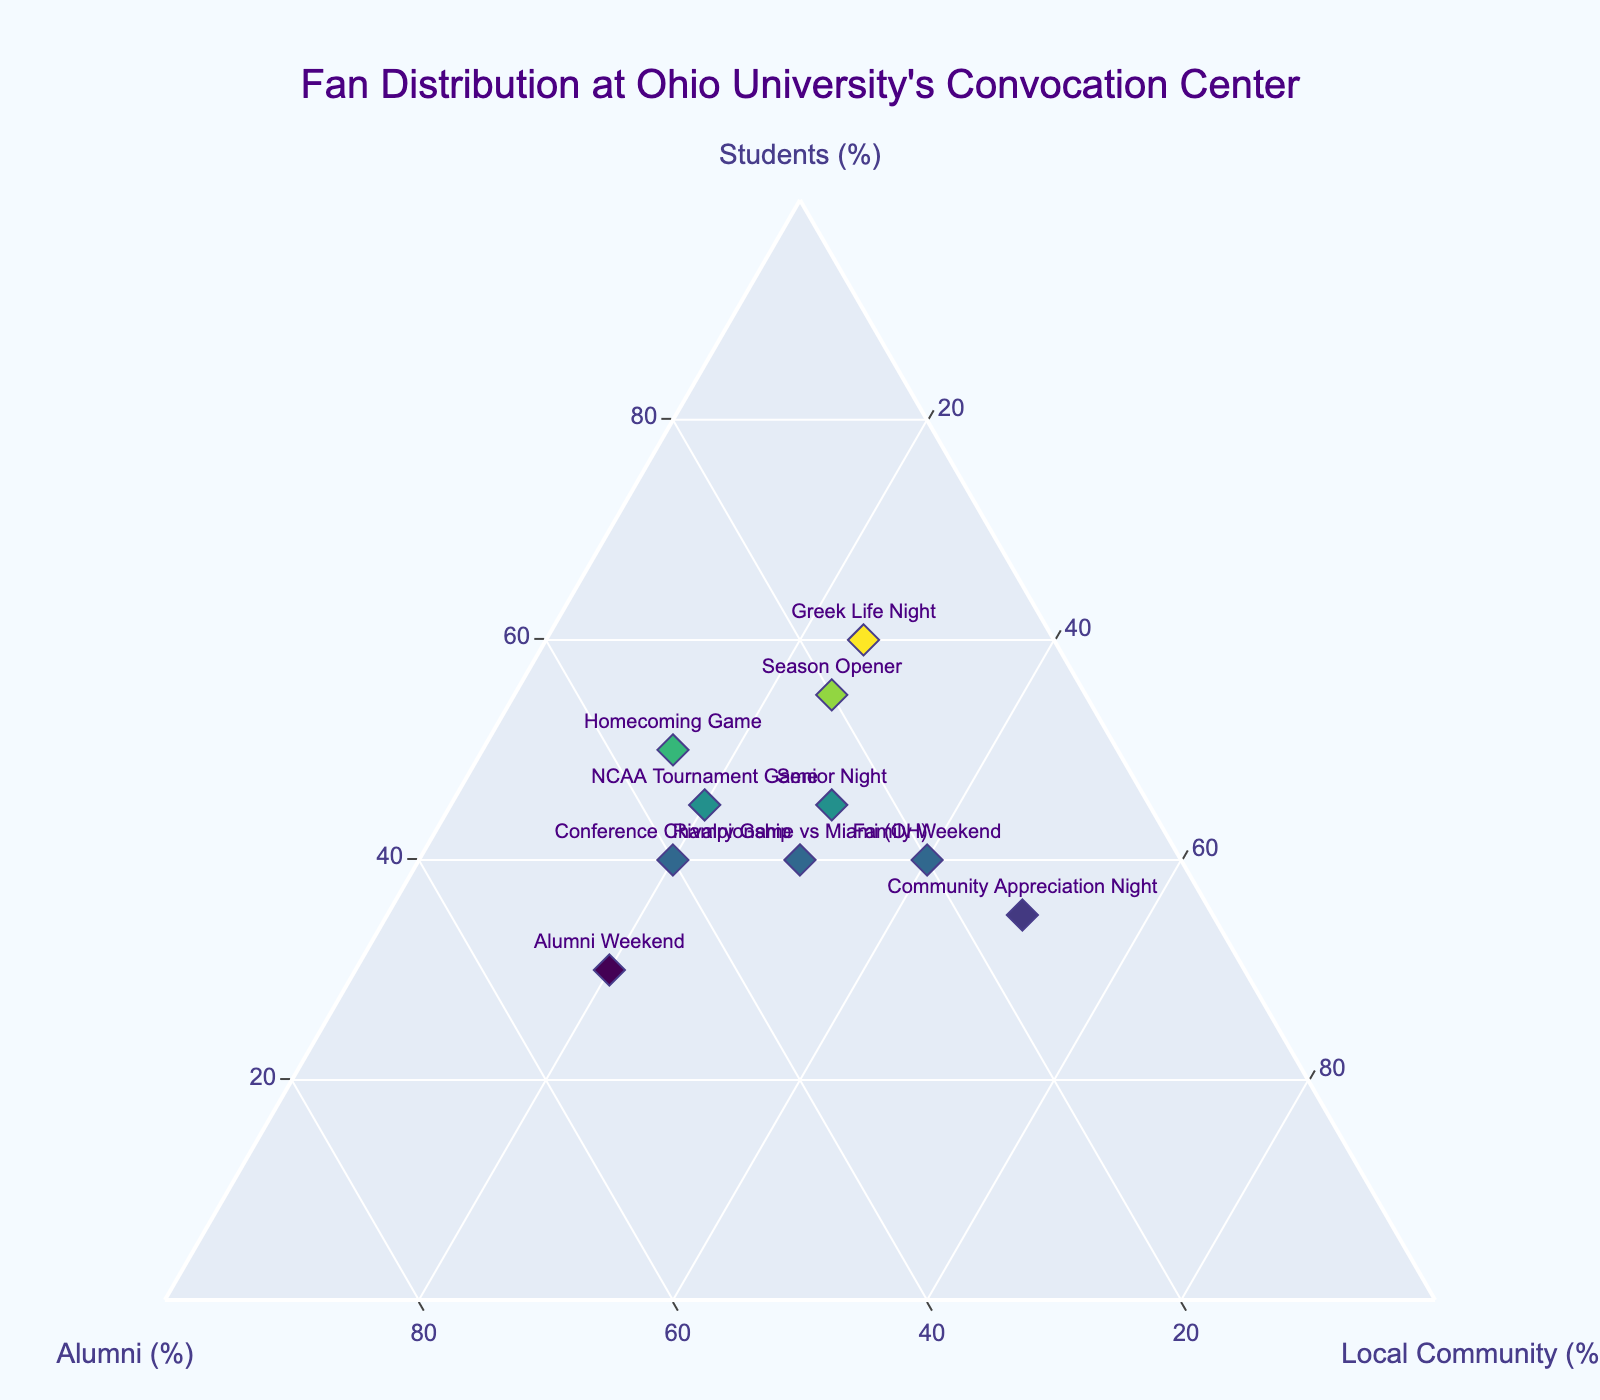What is the title of the figure? The title is prominently displayed at the top of the plot.
Answer: Fan Distribution at Ohio University's Convocation Center Which event had the highest percentage of students in attendance? The event with the highest percentage of students can be identified by locating the point highest on the "Students (%)" axis.
Answer: Greek Life Night Which event had the lowest percentage of alumni in attendance? To identify the event with the lowest alumni attendance, look for the point lowest on the "Alumni (%)" axis.
Answer: Community Appreciation Night Which events had equal percentages of alumni? Compare the positions of the data points along the "Alumni (%)" axis; events at the same level have equal percentages.
Answer: Senior Night and Rivalry Game vs Miami (OH) How many events have a higher percentage of local community members than alumni? Count the data points where the "Local Community (%)" values are greater than the "Alumni (%)" values.
Answer: 5 What is the average percentage of students in attendance for all events? Sum the percentages of students for all events and divide by the number of events: (50 + 45 + 40 + 55 + 30 + 35 + 45 + 40 + 60 + 40) / 10 = 44
Answer: 44 Which event has the highest percentage of local community members, and what is that percentage? Identify the point highest on the "Local Community (%)" axis and note the percentage associated with that point.
Answer: Community Appreciation Night, 50 Which event had the same percentage of alumni and local community members in attendance? Find the point where the values of the "Alumni (%)" and "Local Community (%)" axes are equal.
Answer: Rivalry Game vs Miami (OH) What is the total percentage of students in attendance for the Season Opener and Greek Life Night combined? Sum the percentages of students for both events: 55 + 60 = 115
Answer: 115 For Alumni Weekend, what percentage of the total attendance was made up of students and local community members combined? Sum the percentages of students and local community for Alumni Weekend: 30 + 20 = 50
Answer: 50 